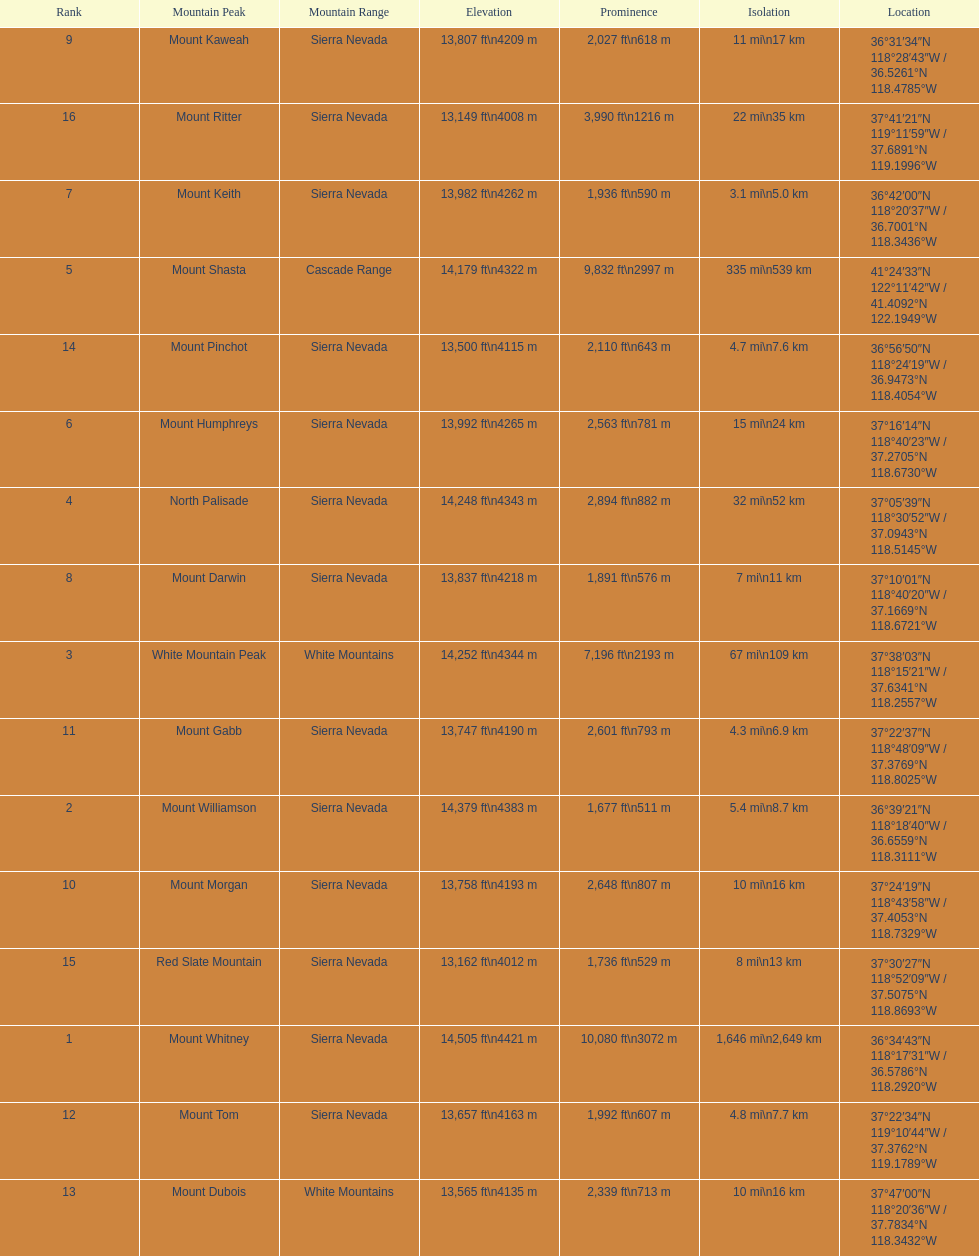Which is taller, mount humphreys or mount kaweah. Mount Humphreys. 